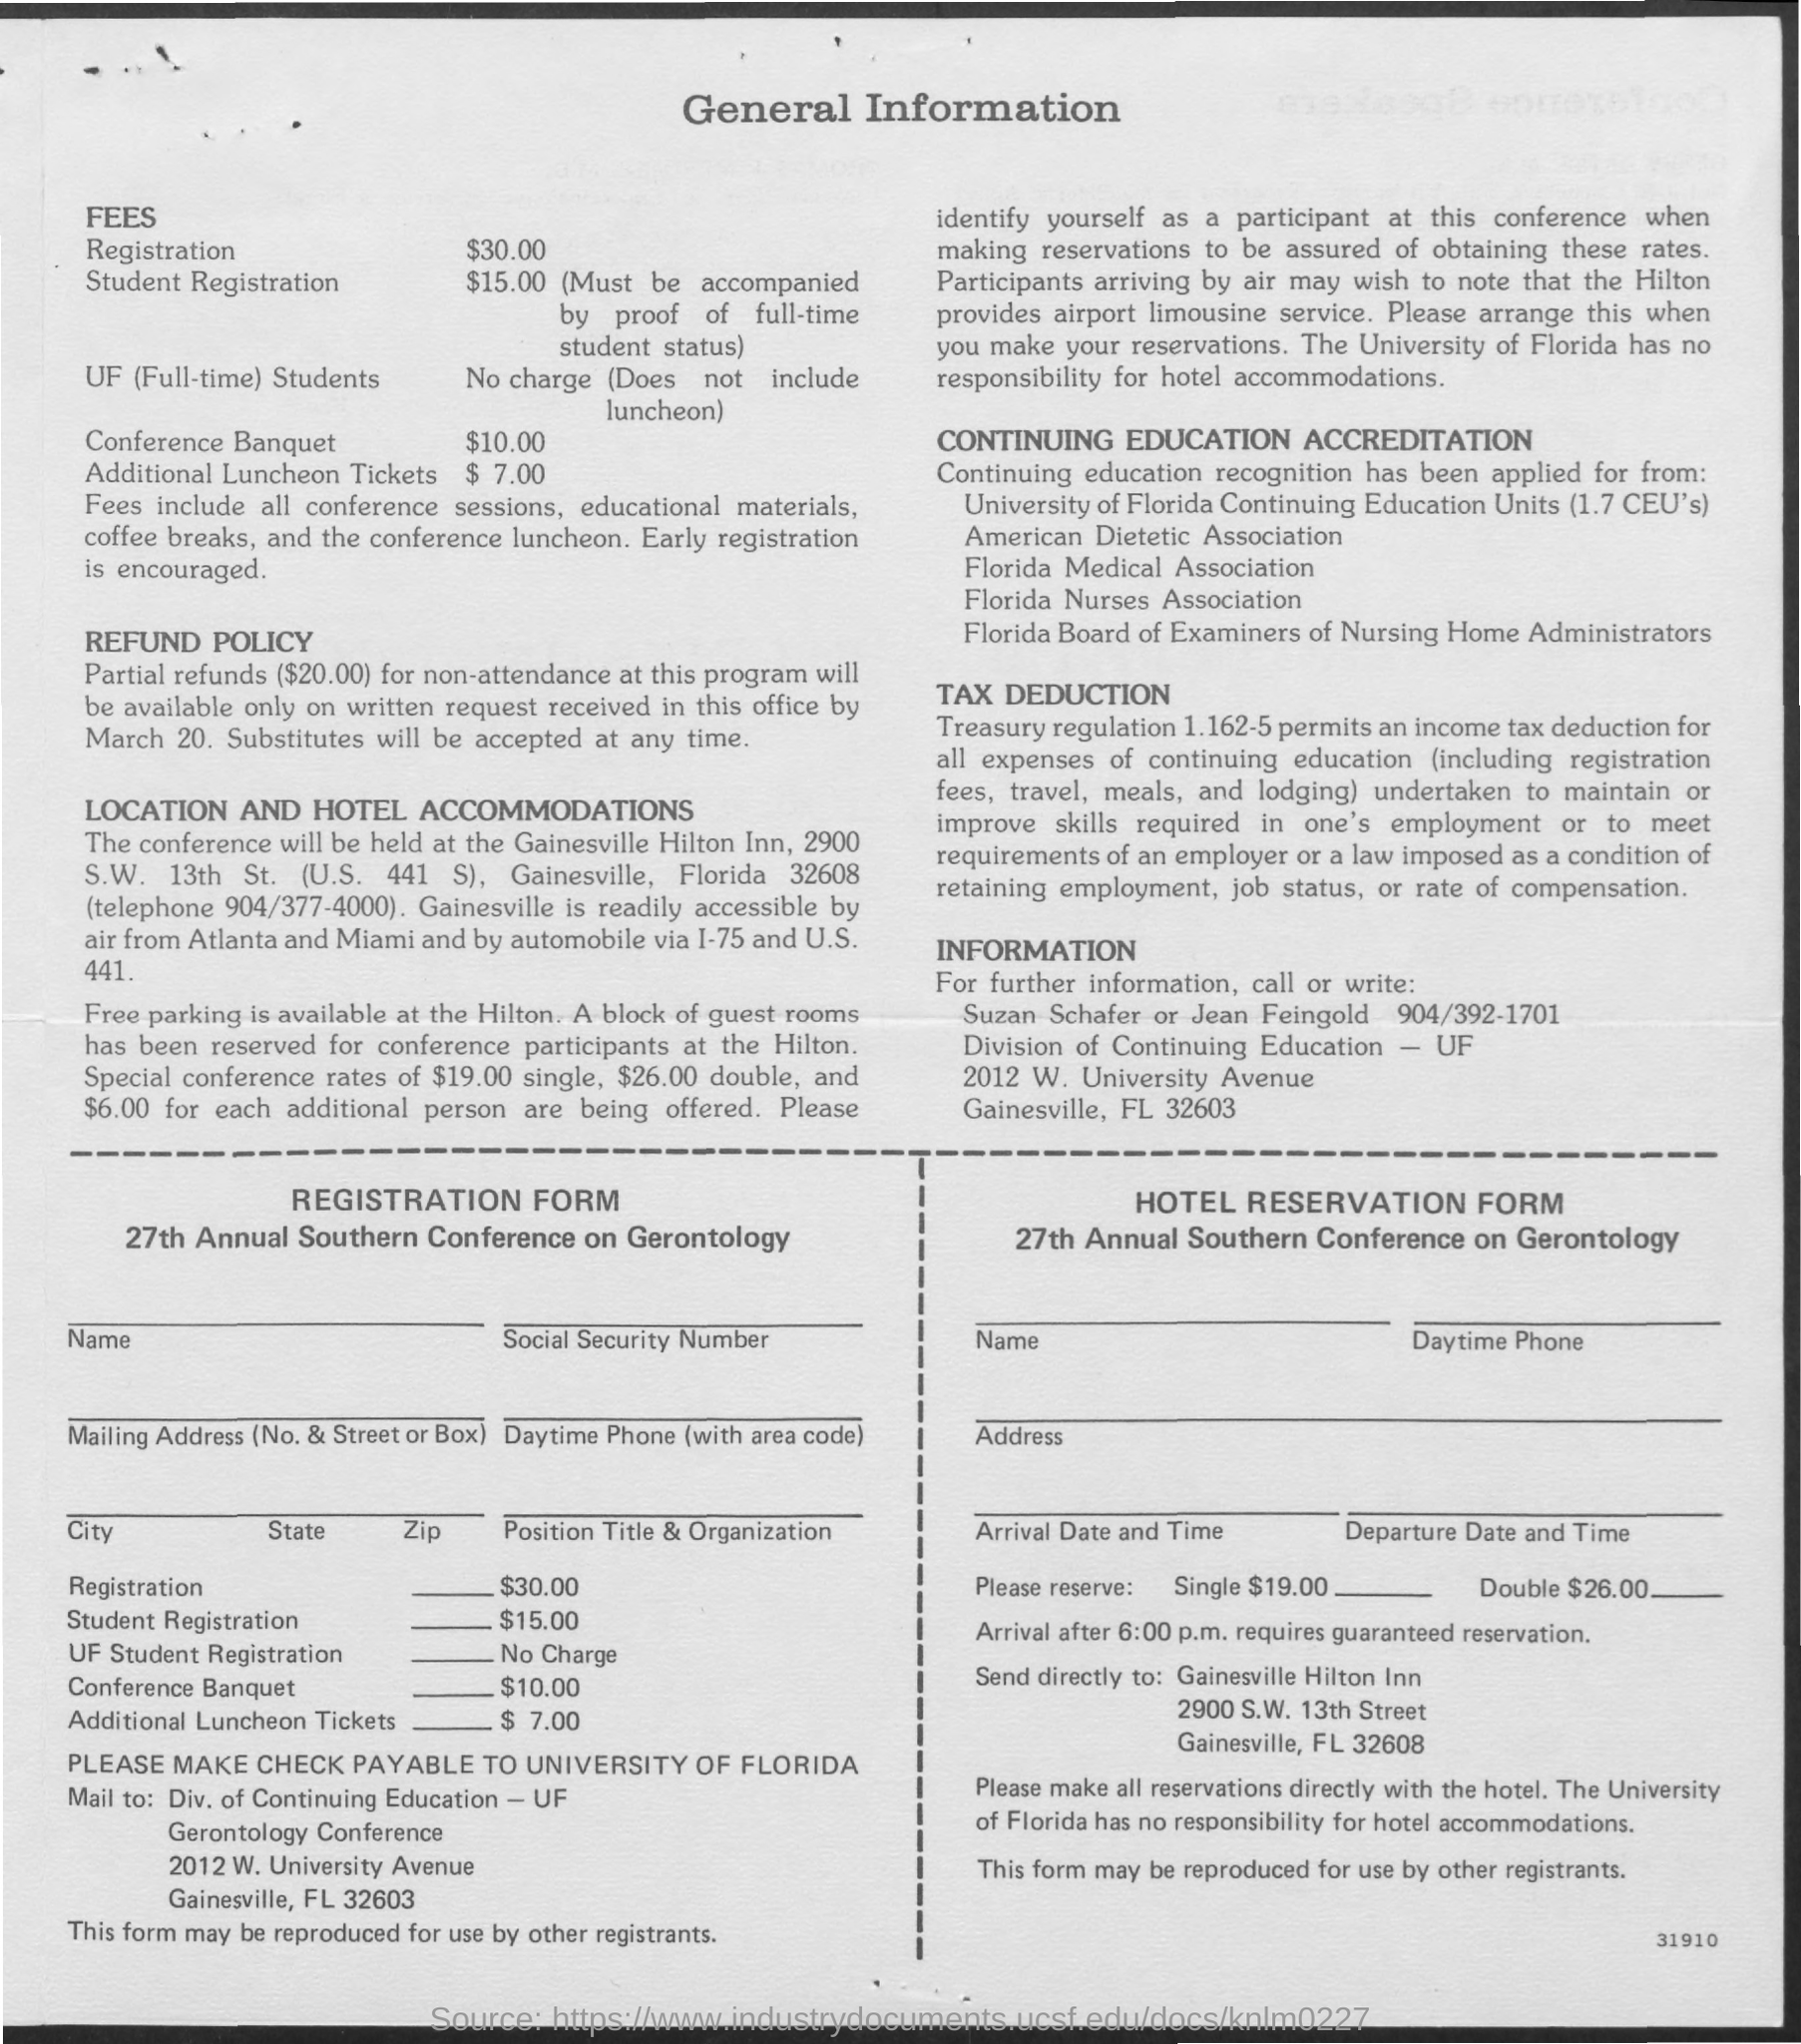Mention a couple of crucial points in this snapshot. The registration fee for UF students for the 27th Annual Southern Conference on Gerontology is waived, meaning there is no charge for them to attend. The student registration fee for the 27th Annual Southern Conference on Gerontology is $15.00. The Conference Banquet costs $10.00. The registration fee for the 27th Annual Southern Conference on Gerontology is $30.00. 